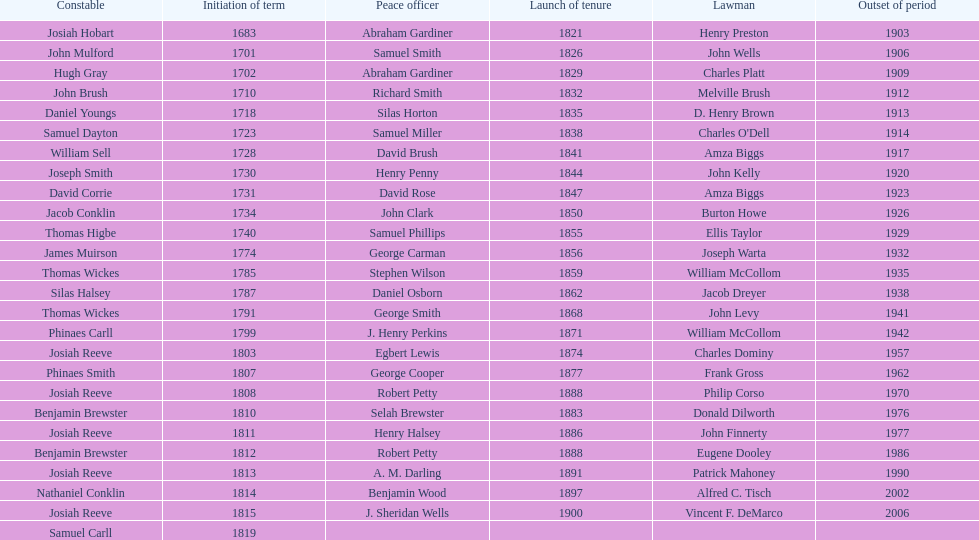Who occupied the sheriff role prior to thomas wickes? James Muirson. 